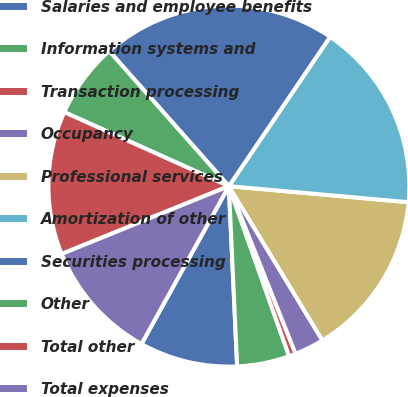Convert chart. <chart><loc_0><loc_0><loc_500><loc_500><pie_chart><fcel>Salaries and employee benefits<fcel>Information systems and<fcel>Transaction processing<fcel>Occupancy<fcel>Professional services<fcel>Amortization of other<fcel>Securities processing<fcel>Other<fcel>Total other<fcel>Total expenses<nl><fcel>8.78%<fcel>4.69%<fcel>0.61%<fcel>2.65%<fcel>14.9%<fcel>16.94%<fcel>21.02%<fcel>6.74%<fcel>12.86%<fcel>10.82%<nl></chart> 